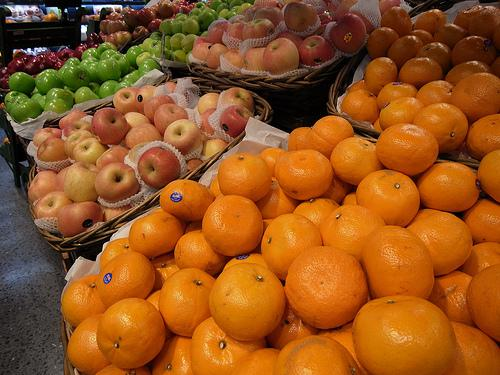Question: why is the fruit on display?
Choices:
A. To take a picture.
B. For sale to shoppers.
C. For guests to eat.
D. To win in a contest.
Answer with the letter. Answer: B Question: how is the fruit arranged?
Choices:
A. Randomly.
B. By color.
C. In piles.
D. By type.
Answer with the letter. Answer: C Question: what are the orange objects?
Choices:
A. Oranges.
B. Bottles.
C. Glass.
D. Peppers.
Answer with the letter. Answer: A Question: where is this taken?
Choices:
A. The deli.
B. The bakery.
C. Frozen foods section.
D. The produce section.
Answer with the letter. Answer: D 